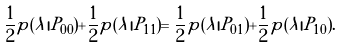Convert formula to latex. <formula><loc_0><loc_0><loc_500><loc_500>\frac { 1 } { 2 } p ( \lambda | P _ { 0 0 } ) + \frac { 1 } { 2 } p ( \lambda | P _ { 1 1 } ) = \frac { 1 } { 2 } p ( \lambda | P _ { 0 1 } ) + \frac { 1 } { 2 } p ( \lambda | P _ { 1 0 } ) .</formula> 